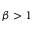<formula> <loc_0><loc_0><loc_500><loc_500>\beta > 1</formula> 